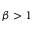<formula> <loc_0><loc_0><loc_500><loc_500>\beta > 1</formula> 